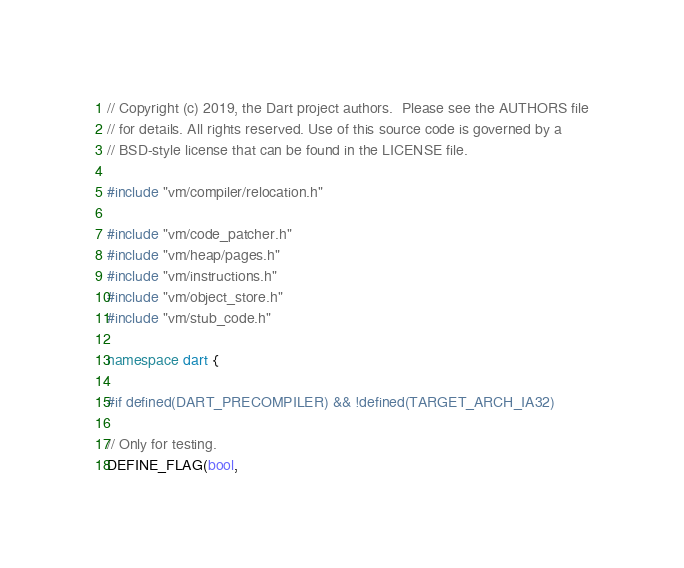<code> <loc_0><loc_0><loc_500><loc_500><_C++_>// Copyright (c) 2019, the Dart project authors.  Please see the AUTHORS file
// for details. All rights reserved. Use of this source code is governed by a
// BSD-style license that can be found in the LICENSE file.

#include "vm/compiler/relocation.h"

#include "vm/code_patcher.h"
#include "vm/heap/pages.h"
#include "vm/instructions.h"
#include "vm/object_store.h"
#include "vm/stub_code.h"

namespace dart {

#if defined(DART_PRECOMPILER) && !defined(TARGET_ARCH_IA32)

// Only for testing.
DEFINE_FLAG(bool,</code> 